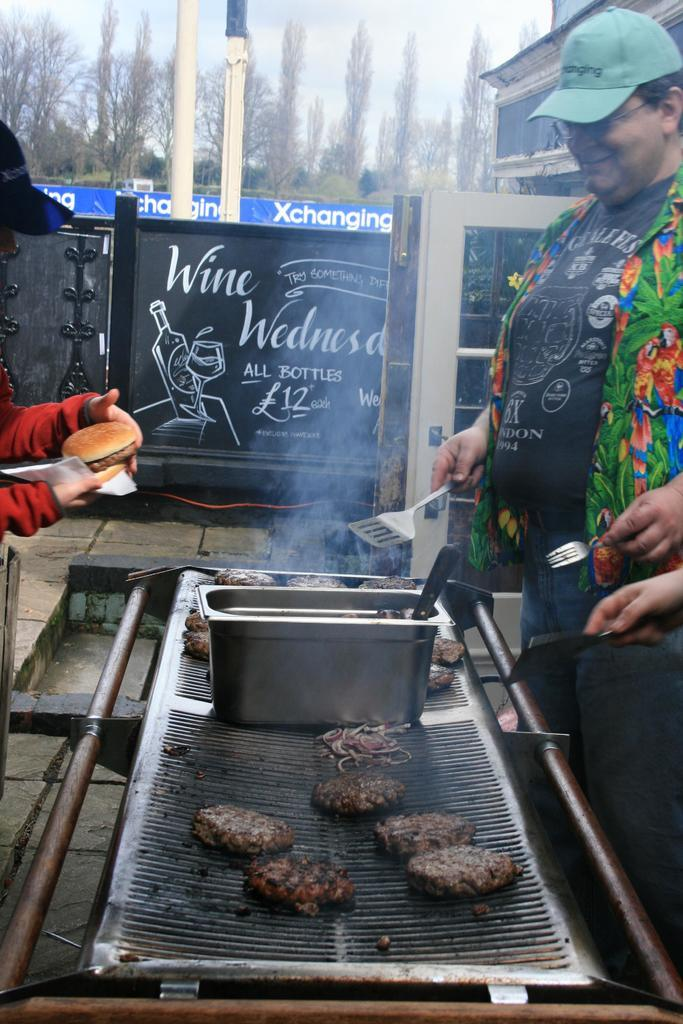<image>
Write a terse but informative summary of the picture. A man grills burgers and onions on a grill in front of a sign that reads Wine Wednesday. 